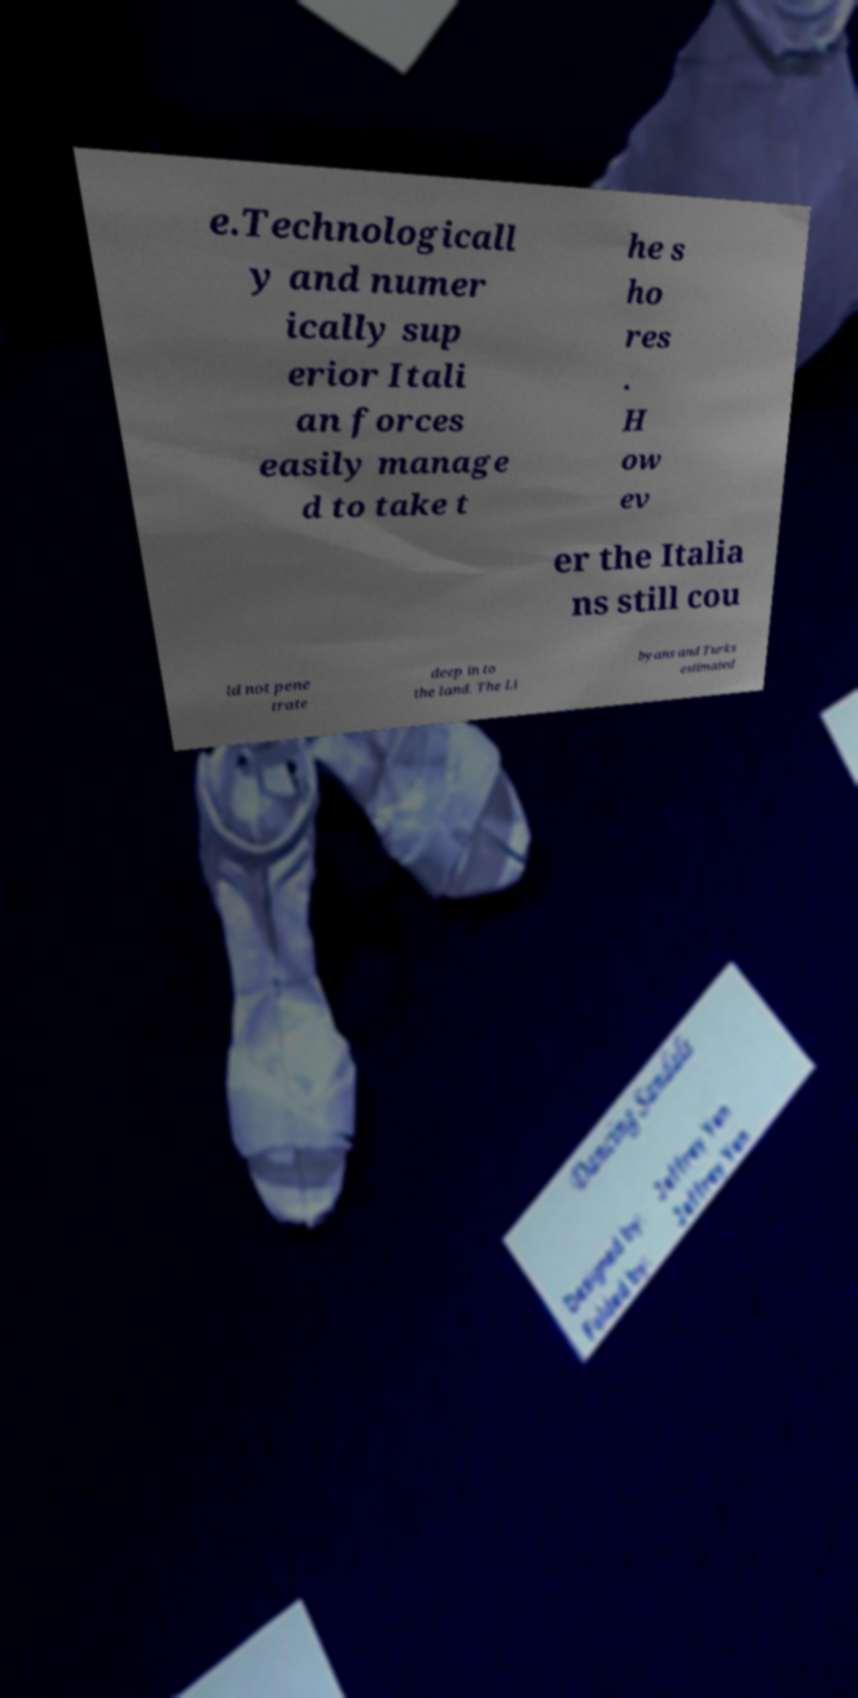Please read and relay the text visible in this image. What does it say? e.Technologicall y and numer ically sup erior Itali an forces easily manage d to take t he s ho res . H ow ev er the Italia ns still cou ld not pene trate deep in to the land. The Li byans and Turks estimated 